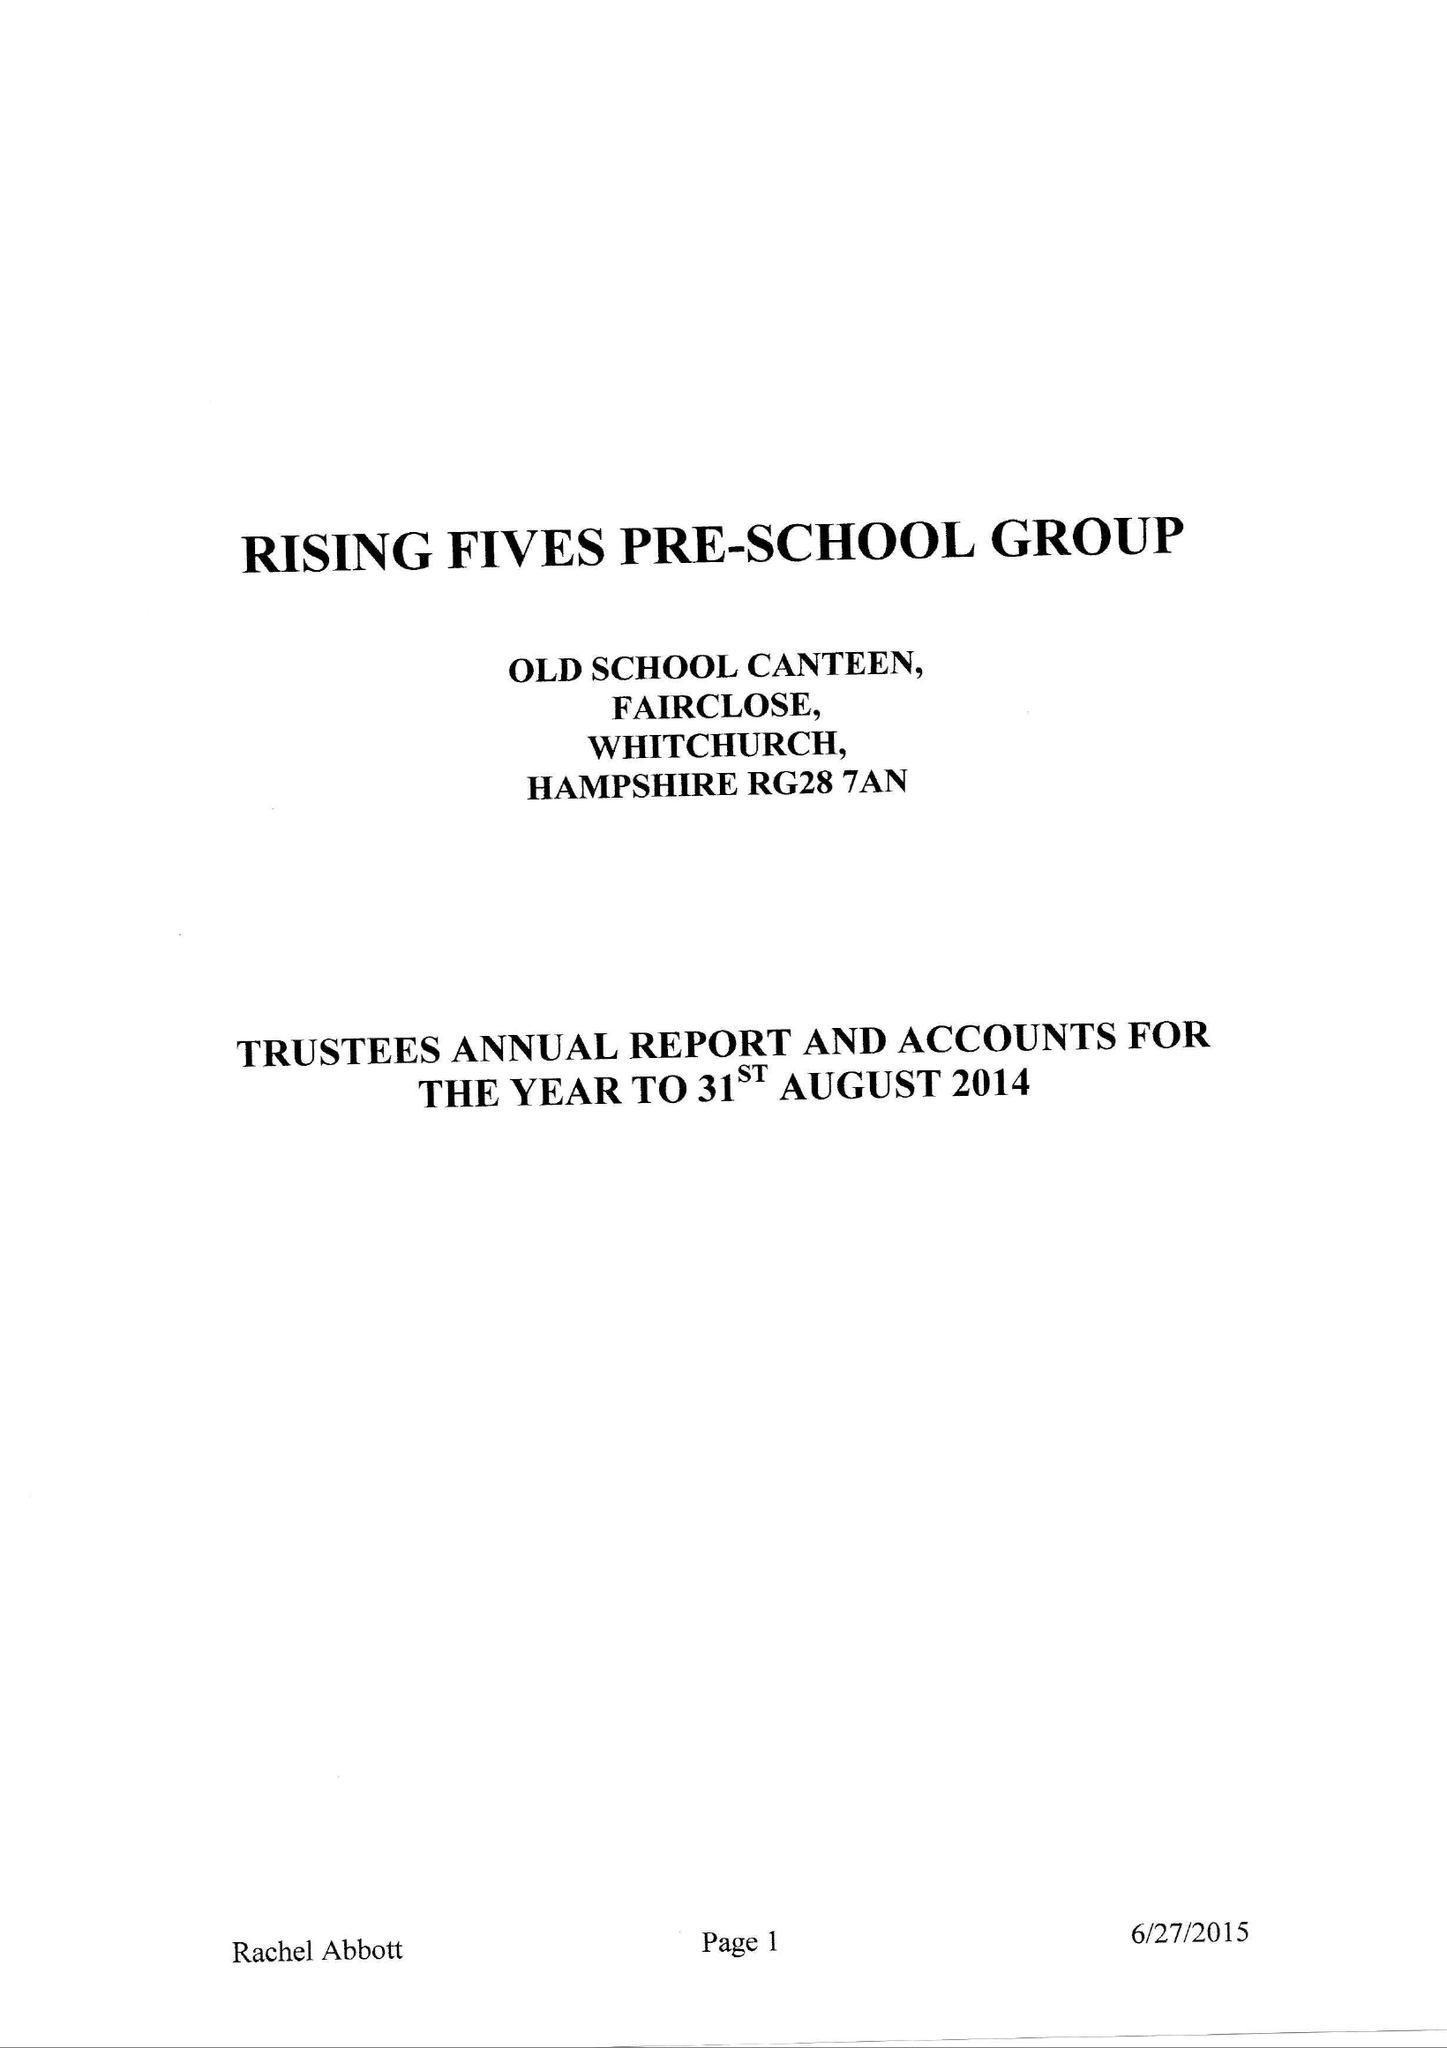What is the value for the address__street_line?
Answer the question using a single word or phrase. WELLS LANE 